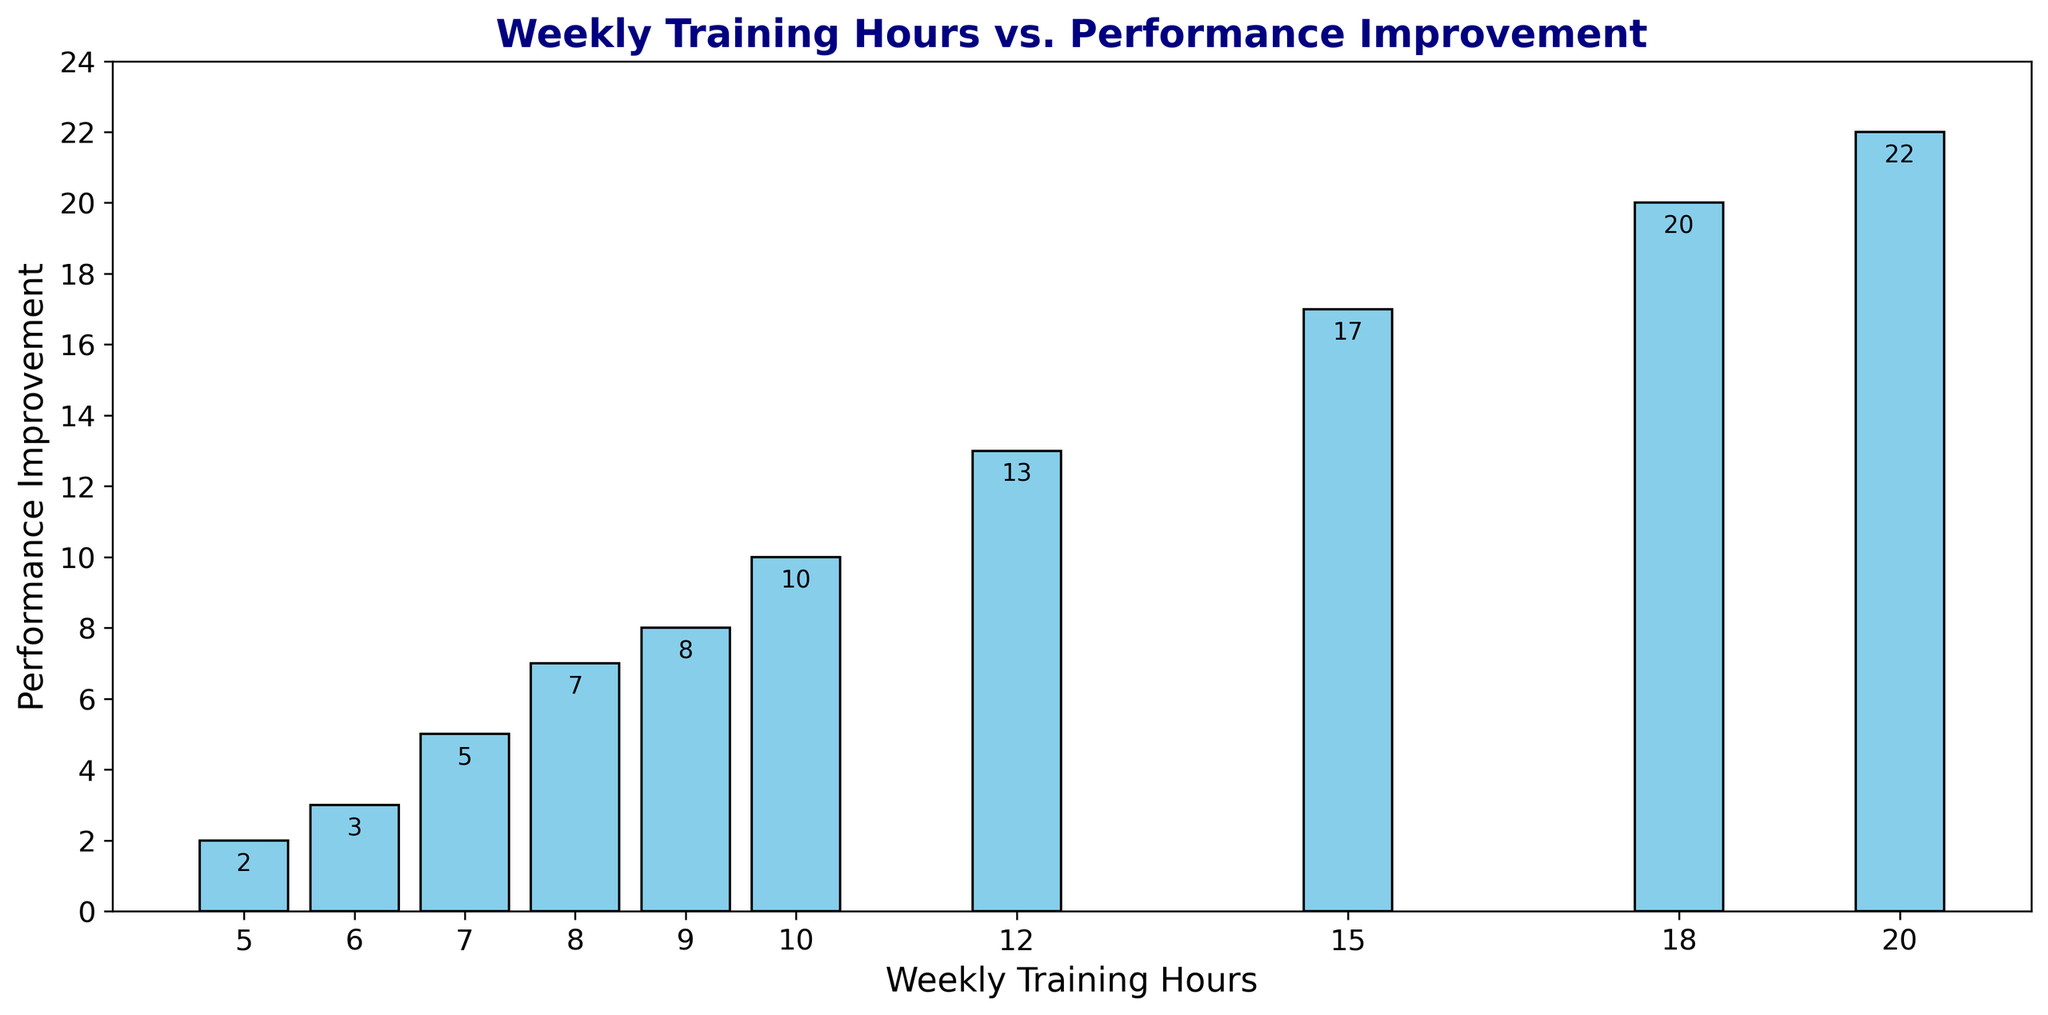What is the performance improvement for 12 weekly training hours? Look at the bar corresponding to 12 weekly training hours and read the height of the bar to find the performance improvement value.
Answer: 13 Which Weekly Training Hours value corresponds to the highest performance improvement? Find the bar with the highest value on the y-axis and note the x-axis value corresponding to it.
Answer: 20 What is the difference in performance improvement between 20 and 10 weekly training hours? Identify the performance improvement values for 20 and 10 weekly training hours. Subtract the value for 10 from the value for 20.
Answer: 12 How many weekly training hours show performance improvement of more than 10? Look for bars with heights greater than 10 and count the corresponding weekly training hours.
Answer: 4 What is the performance improvement per hour for 7 weekly training hours? Find the performance improvement for 7 weekly training hours and divide it by 7.
Answer: 0.71 Which weekly training hours provide an improvement between 5 and 10? Identify all bars with performance values between 5 and 10 and note their corresponding weekly training hours.
Answer: 7, 8, 9, 10 What is the average performance improvement for 8, 10, and 12 weekly training hours? Find the performance improvement values for 8, 10, and 12 weekly training hours, sum them up, and divide by 3.
Answer: 10 What is the sum of performance improvements for training hours of 6, 12, and 15? Add the performance improvement values corresponding to 6, 12, and 15 weekly training hours.
Answer: 33 Is there a linear relationship between training hours and performance improvement? Examine the pattern by observing the incremental changes in performance improvement for increasing training hours.
Answer: Yes, roughly Which training hour values have the closest performance improvements? Compare adjacent bars to identify pairs with minimal height differences.
Answer: 9 and 10 